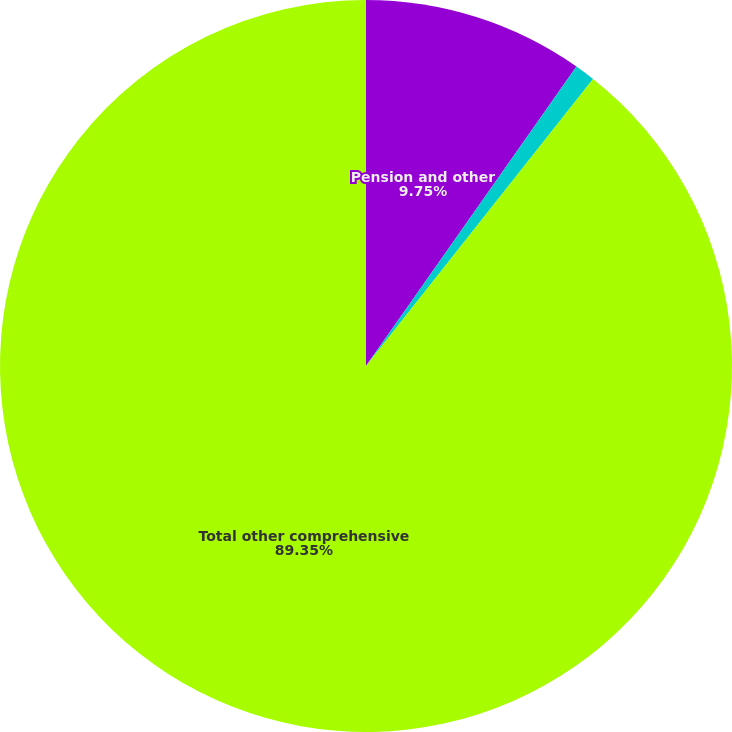Convert chart to OTSL. <chart><loc_0><loc_0><loc_500><loc_500><pie_chart><fcel>Pension and other<fcel>Changes in fair value of cash<fcel>Total other comprehensive<nl><fcel>9.75%<fcel>0.9%<fcel>89.35%<nl></chart> 